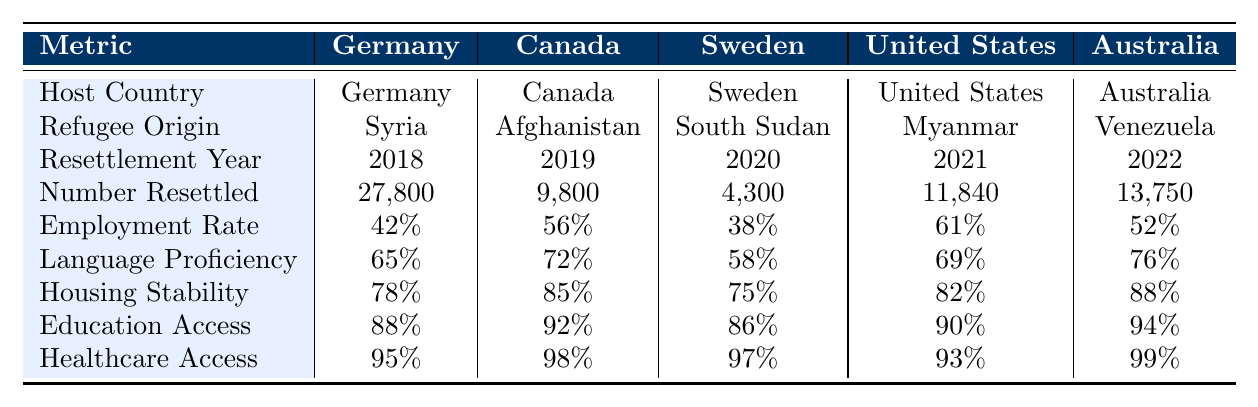What is the highest number of refugees resettled among the listed countries? In the table, Germany has the highest number of refugees resettled at 27,800, compared to the other countries listed.
Answer: 27,800 Which country has the lowest employment rate among the resettled refugees? The employment rate for South Sudan in Sweden is 38%, which is the lowest compared to all other countries.
Answer: South Sudan (Sweden) What is the average language proficiency among the listed host countries? Adding the language proficiency rates: (65% + 72% + 58% + 69% + 76%) equals 340%. Dividing by the number of countries (5) gives 340% / 5 = 68%.
Answer: 68% Is there a significant difference in healthcare access between Canada and Australia? Canada has a healthcare access rate of 98%, while Australia has 99%. The difference is 1%, indicating that both have very high healthcare access but Australia is slightly better.
Answer: No What is the percentage of refugees with housing stability in the United States? The table shows that the housing stability for refugees in the United States is 82%.
Answer: 82% If you compare education access rates, which country shows the greatest percentage? Education access in Australia is 94%, which is higher than Canada (92%), Sweden (86%), the United States (90%), and Germany (88%).
Answer: Australia Which two countries have comparable language proficiency and how do they compare? Sweden has a language proficiency of 58%, while the United States has 69%. The difference is 11%, with the United States having higher proficiency.
Answer: United States has higher proficiency than Sweden by 11% What is the total number of refugees resettled across all countries listed? The total is found by summing all the number resettled: (27,800 + 9,800 + 4,300 + 11,840 + 13,750) = 67,990.
Answer: 67,990 Which country has the highest education access, and what is that percentage? Australia has the highest education access rate at 94%.
Answer: Australia, 94% Was the number of refugees resettled from Myanmar in the United States greater than those from Venezuela in Australia? The number of refugees resettled from Myanmar is 11,840, while from Venezuela it is 13,750. Therefore, fewer were resettled from Myanmar.
Answer: No, fewer were resettled from Myanmar 